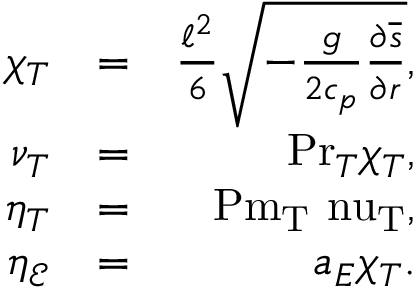Convert formula to latex. <formula><loc_0><loc_0><loc_500><loc_500>\begin{array} { r l r } { \chi _ { T } } & { = } & { \frac { \ell ^ { 2 } } { 6 } \sqrt { - \frac { g } { 2 c _ { p } } \frac { \partial \overline { s } } { \partial r } } , } \\ { \nu _ { T } } & { = } & { P r _ { T } \chi _ { T } , } \\ { \eta _ { T } } & { = } & { P m _ { T } \ n u _ { T } , } \\ { \eta _ { \mathcal { E } } } & { = } & { a _ { E } \chi _ { T } . } \end{array}</formula> 